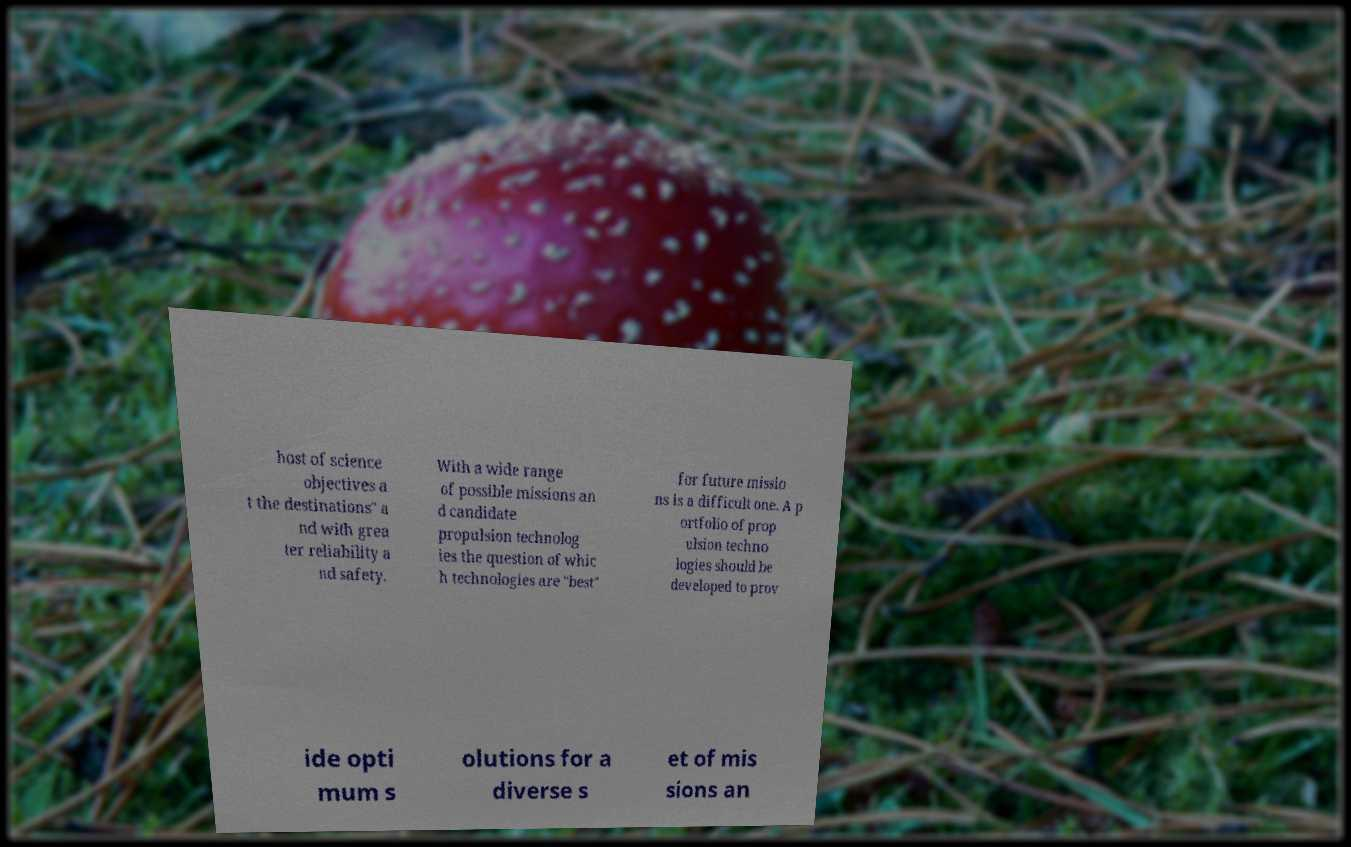Please identify and transcribe the text found in this image. host of science objectives a t the destinations" a nd with grea ter reliability a nd safety. With a wide range of possible missions an d candidate propulsion technolog ies the question of whic h technologies are "best" for future missio ns is a difficult one. A p ortfolio of prop ulsion techno logies should be developed to prov ide opti mum s olutions for a diverse s et of mis sions an 